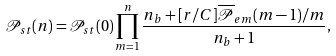Convert formula to latex. <formula><loc_0><loc_0><loc_500><loc_500>\mathcal { P } _ { s t } ( n ) = \mathcal { P } _ { s t } ( 0 ) \prod _ { m = 1 } ^ { n } \frac { n _ { b } + [ r / C ] \overline { \mathcal { P } } _ { e m } ( m - 1 ) / m } { n _ { b } + 1 } ,</formula> 